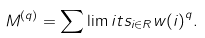Convert formula to latex. <formula><loc_0><loc_0><loc_500><loc_500>M ^ { ( q ) } = \sum \lim i t s _ { i \in R } { w ( i ) } ^ { q } .</formula> 